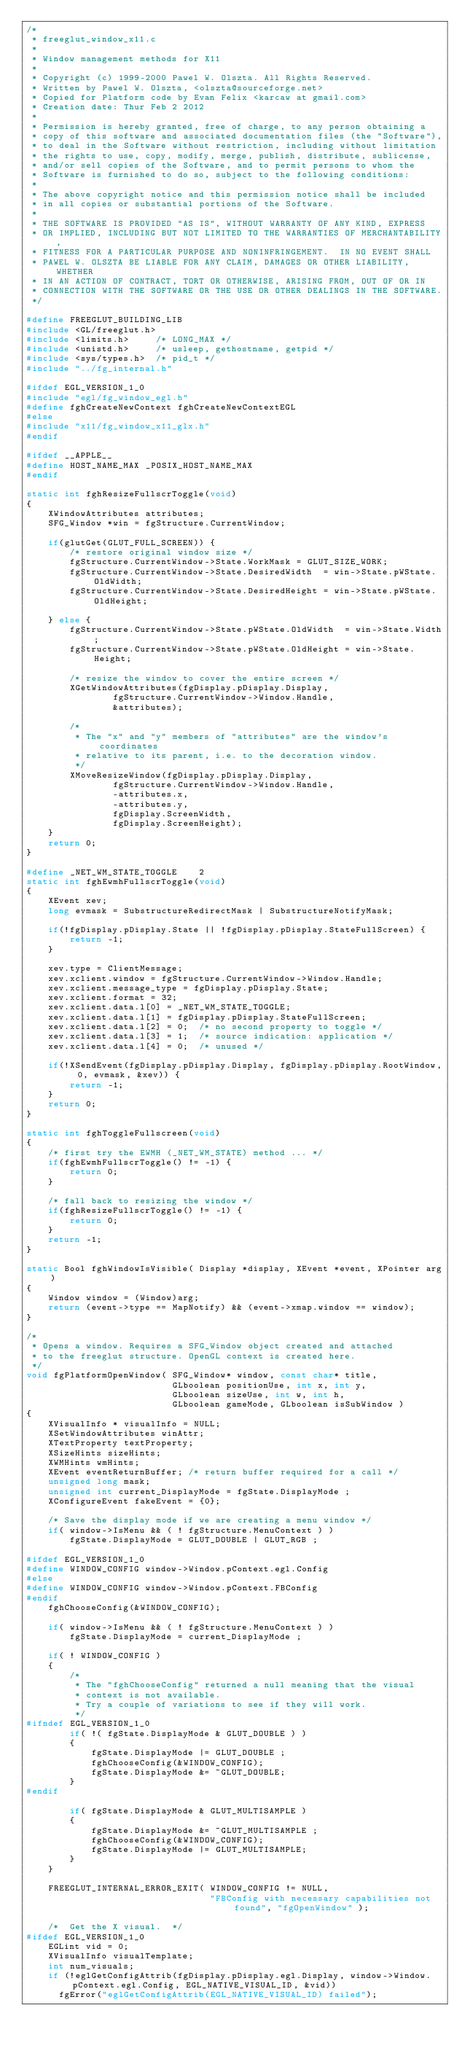Convert code to text. <code><loc_0><loc_0><loc_500><loc_500><_C_>/*
 * freeglut_window_x11.c
 *
 * Window management methods for X11
 *
 * Copyright (c) 1999-2000 Pawel W. Olszta. All Rights Reserved.
 * Written by Pawel W. Olszta, <olszta@sourceforge.net>
 * Copied for Platform code by Evan Felix <karcaw at gmail.com>
 * Creation date: Thur Feb 2 2012
 *
 * Permission is hereby granted, free of charge, to any person obtaining a
 * copy of this software and associated documentation files (the "Software"),
 * to deal in the Software without restriction, including without limitation
 * the rights to use, copy, modify, merge, publish, distribute, sublicense,
 * and/or sell copies of the Software, and to permit persons to whom the
 * Software is furnished to do so, subject to the following conditions:
 *
 * The above copyright notice and this permission notice shall be included
 * in all copies or substantial portions of the Software.
 *
 * THE SOFTWARE IS PROVIDED "AS IS", WITHOUT WARRANTY OF ANY KIND, EXPRESS
 * OR IMPLIED, INCLUDING BUT NOT LIMITED TO THE WARRANTIES OF MERCHANTABILITY,
 * FITNESS FOR A PARTICULAR PURPOSE AND NONINFRINGEMENT.  IN NO EVENT SHALL
 * PAWEL W. OLSZTA BE LIABLE FOR ANY CLAIM, DAMAGES OR OTHER LIABILITY, WHETHER
 * IN AN ACTION OF CONTRACT, TORT OR OTHERWISE, ARISING FROM, OUT OF OR IN
 * CONNECTION WITH THE SOFTWARE OR THE USE OR OTHER DEALINGS IN THE SOFTWARE.
 */

#define FREEGLUT_BUILDING_LIB
#include <GL/freeglut.h>
#include <limits.h>     /* LONG_MAX */
#include <unistd.h>     /* usleep, gethostname, getpid */
#include <sys/types.h>  /* pid_t */
#include "../fg_internal.h"

#ifdef EGL_VERSION_1_0
#include "egl/fg_window_egl.h"
#define fghCreateNewContext fghCreateNewContextEGL
#else
#include "x11/fg_window_x11_glx.h"
#endif

#ifdef __APPLE__
#define HOST_NAME_MAX _POSIX_HOST_NAME_MAX
#endif

static int fghResizeFullscrToggle(void)
{
    XWindowAttributes attributes;
    SFG_Window *win = fgStructure.CurrentWindow;

    if(glutGet(GLUT_FULL_SCREEN)) {
        /* restore original window size */
        fgStructure.CurrentWindow->State.WorkMask = GLUT_SIZE_WORK;
        fgStructure.CurrentWindow->State.DesiredWidth  = win->State.pWState.OldWidth;
        fgStructure.CurrentWindow->State.DesiredHeight = win->State.pWState.OldHeight;

    } else {
        fgStructure.CurrentWindow->State.pWState.OldWidth  = win->State.Width;
        fgStructure.CurrentWindow->State.pWState.OldHeight = win->State.Height;

        /* resize the window to cover the entire screen */
        XGetWindowAttributes(fgDisplay.pDisplay.Display,
                fgStructure.CurrentWindow->Window.Handle,
                &attributes);
        
        /*
         * The "x" and "y" members of "attributes" are the window's coordinates
         * relative to its parent, i.e. to the decoration window.
         */
        XMoveResizeWindow(fgDisplay.pDisplay.Display,
                fgStructure.CurrentWindow->Window.Handle,
                -attributes.x,
                -attributes.y,
                fgDisplay.ScreenWidth,
                fgDisplay.ScreenHeight);
    }
    return 0;
}

#define _NET_WM_STATE_TOGGLE    2
static int fghEwmhFullscrToggle(void)
{
    XEvent xev;
    long evmask = SubstructureRedirectMask | SubstructureNotifyMask;

    if(!fgDisplay.pDisplay.State || !fgDisplay.pDisplay.StateFullScreen) {
        return -1;
    }

    xev.type = ClientMessage;
    xev.xclient.window = fgStructure.CurrentWindow->Window.Handle;
    xev.xclient.message_type = fgDisplay.pDisplay.State;
    xev.xclient.format = 32;
    xev.xclient.data.l[0] = _NET_WM_STATE_TOGGLE;
    xev.xclient.data.l[1] = fgDisplay.pDisplay.StateFullScreen;
    xev.xclient.data.l[2] = 0;	/* no second property to toggle */
    xev.xclient.data.l[3] = 1;	/* source indication: application */
    xev.xclient.data.l[4] = 0;	/* unused */

    if(!XSendEvent(fgDisplay.pDisplay.Display, fgDisplay.pDisplay.RootWindow, 0, evmask, &xev)) {
        return -1;
    }
    return 0;
}

static int fghToggleFullscreen(void)
{
    /* first try the EWMH (_NET_WM_STATE) method ... */
    if(fghEwmhFullscrToggle() != -1) {
        return 0;
    }

    /* fall back to resizing the window */
    if(fghResizeFullscrToggle() != -1) {
        return 0;
    }
    return -1;
}

static Bool fghWindowIsVisible( Display *display, XEvent *event, XPointer arg)
{
    Window window = (Window)arg;
    return (event->type == MapNotify) && (event->xmap.window == window);
}

/*
 * Opens a window. Requires a SFG_Window object created and attached
 * to the freeglut structure. OpenGL context is created here.
 */
void fgPlatformOpenWindow( SFG_Window* window, const char* title,
                           GLboolean positionUse, int x, int y,
                           GLboolean sizeUse, int w, int h,
                           GLboolean gameMode, GLboolean isSubWindow )
{
    XVisualInfo * visualInfo = NULL;
    XSetWindowAttributes winAttr;
    XTextProperty textProperty;
    XSizeHints sizeHints;
    XWMHints wmHints;
    XEvent eventReturnBuffer; /* return buffer required for a call */
    unsigned long mask;
    unsigned int current_DisplayMode = fgState.DisplayMode ;
    XConfigureEvent fakeEvent = {0};

    /* Save the display mode if we are creating a menu window */
    if( window->IsMenu && ( ! fgStructure.MenuContext ) )
        fgState.DisplayMode = GLUT_DOUBLE | GLUT_RGB ;

#ifdef EGL_VERSION_1_0
#define WINDOW_CONFIG window->Window.pContext.egl.Config
#else
#define WINDOW_CONFIG window->Window.pContext.FBConfig
#endif
    fghChooseConfig(&WINDOW_CONFIG);

    if( window->IsMenu && ( ! fgStructure.MenuContext ) )
        fgState.DisplayMode = current_DisplayMode ;

    if( ! WINDOW_CONFIG )
    {
        /*
         * The "fghChooseConfig" returned a null meaning that the visual
         * context is not available.
         * Try a couple of variations to see if they will work.
         */
#ifndef EGL_VERSION_1_0
        if( !( fgState.DisplayMode & GLUT_DOUBLE ) )
        {
            fgState.DisplayMode |= GLUT_DOUBLE ;
            fghChooseConfig(&WINDOW_CONFIG);
            fgState.DisplayMode &= ~GLUT_DOUBLE;
        }
#endif

        if( fgState.DisplayMode & GLUT_MULTISAMPLE )
        {
            fgState.DisplayMode &= ~GLUT_MULTISAMPLE ;
            fghChooseConfig(&WINDOW_CONFIG);
            fgState.DisplayMode |= GLUT_MULTISAMPLE;
        }
    }

    FREEGLUT_INTERNAL_ERROR_EXIT( WINDOW_CONFIG != NULL,
                                  "FBConfig with necessary capabilities not found", "fgOpenWindow" );

    /*  Get the X visual.  */
#ifdef EGL_VERSION_1_0
    EGLint vid = 0;
    XVisualInfo visualTemplate;
    int num_visuals;
    if (!eglGetConfigAttrib(fgDisplay.pDisplay.egl.Display, window->Window.pContext.egl.Config, EGL_NATIVE_VISUAL_ID, &vid))
      fgError("eglGetConfigAttrib(EGL_NATIVE_VISUAL_ID) failed");</code> 